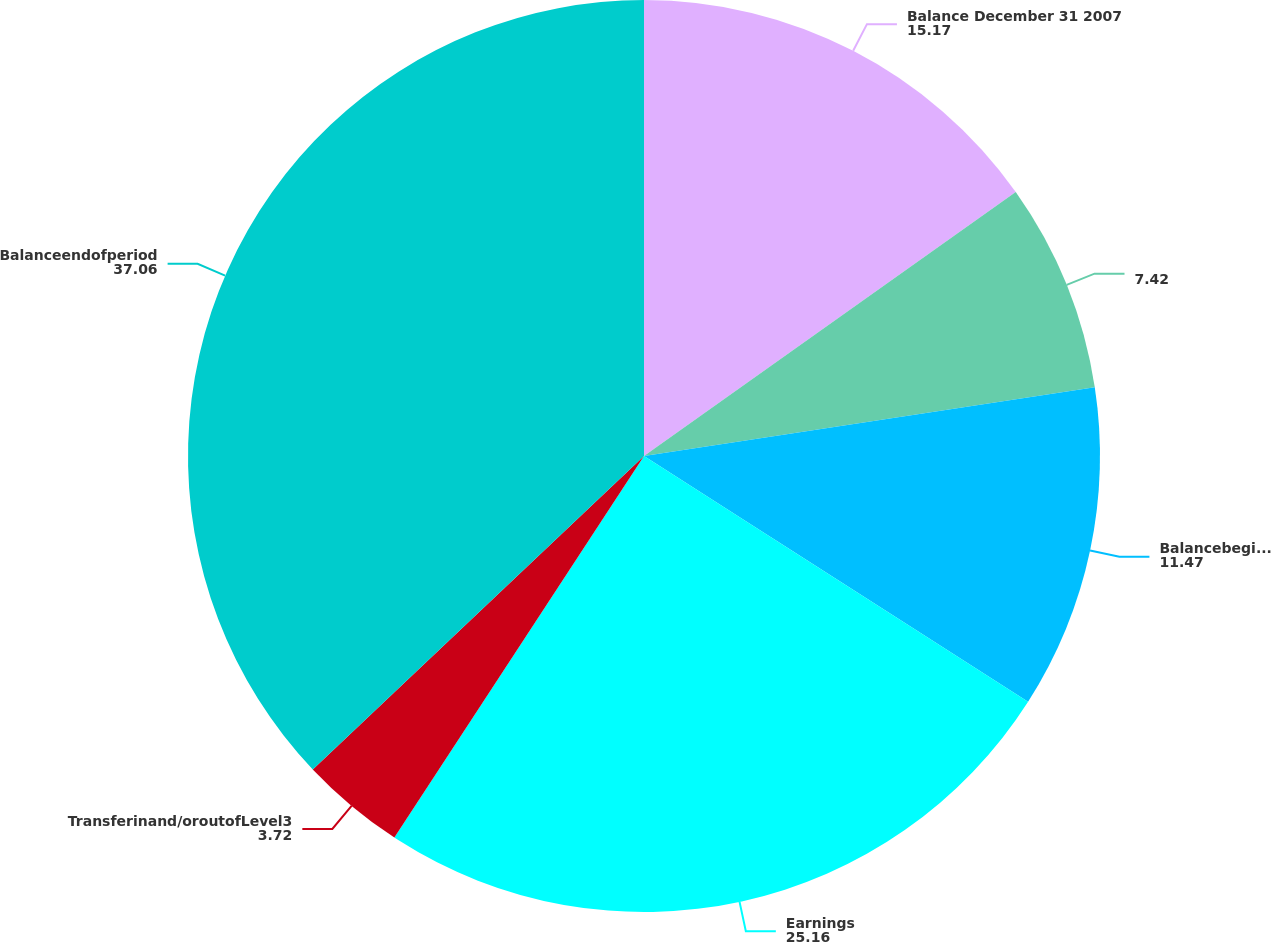Convert chart. <chart><loc_0><loc_0><loc_500><loc_500><pie_chart><fcel>Balance December 31 2007<fcel>Unnamed: 1<fcel>Balancebeginningofperiod<fcel>Earnings<fcel>Transferinand/oroutofLevel3<fcel>Balanceendofperiod<nl><fcel>15.17%<fcel>7.42%<fcel>11.47%<fcel>25.16%<fcel>3.72%<fcel>37.06%<nl></chart> 